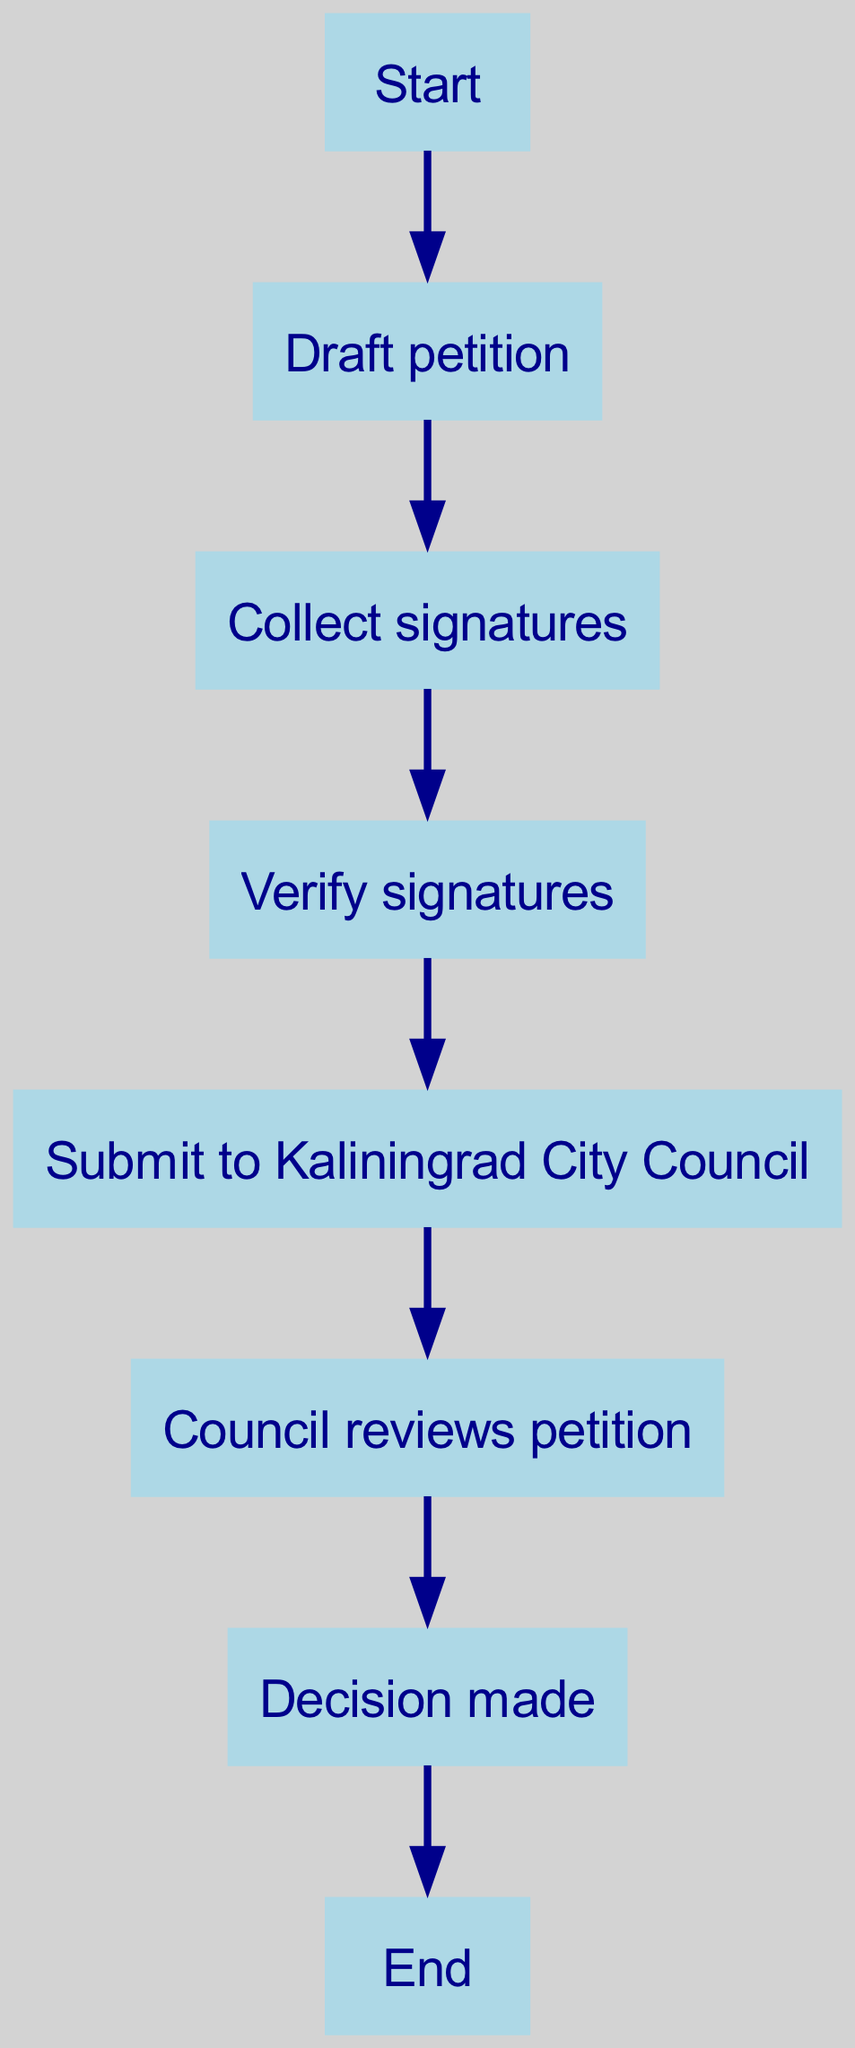What is the first step in the petition process? The first step is represented by the node labeled "Start," which initiates the process before moving to "Draft petition."
Answer: Start How many steps are there in the process of submitting a petition? Counting all the nodes from the start to the end gives a total of 7 steps: Start, Draft petition, Collect signatures, Verify signatures, Submit to Kaliningrad City Council, Council reviews petition, and Decision made.
Answer: 7 What follows after "Collect signatures"? The flow from "Collect signatures" leads directly to "Verify signatures," indicating that verification is the next step in the process.
Answer: Verify signatures What action is taken after the "Council reviews petition"? The next action after the review is a "Decision made," which stems from the council's evaluation of the petition.
Answer: Decision made What two nodes are connected to the "Draft petition"? The "Draft petition" node connects to "Collect signatures," indicating the next action in the process after drafting, as well as to "Start" as its predecessor.
Answer: Collect signatures, Start How does one proceed after gathering signatures? After gathering signatures, the next step is to "Verify signatures," showing the flow of the process that requires verification of the collected signatures before submission.
Answer: Verify signatures What is the endpoint of the petition submission process? The last step or endpoint of the process is represented by the node labeled "End," indicating the completion of the entire petition submission sequence.
Answer: End What is the connecting action between "Submit to Kaliningrad City Council" and "Council reviews petition"? The petition submission directly leads to council review; hence, there is a directed edge from "Submit to Kaliningrad City Council" that goes to "Council reviews petition."
Answer: Council reviews petition What is the relationship between "Decision made" and "End"? "Decision made" connects to "End," showing that once the decision is made, the process concludes.
Answer: End 